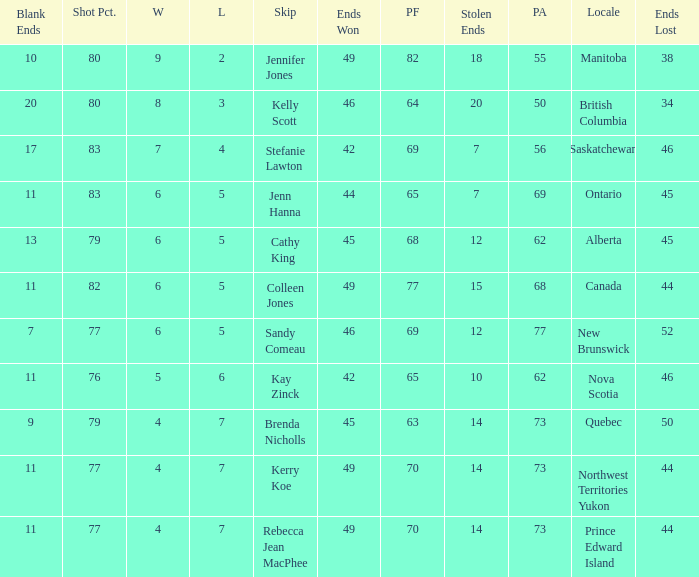What is the PA when the skip is Colleen Jones? 68.0. 